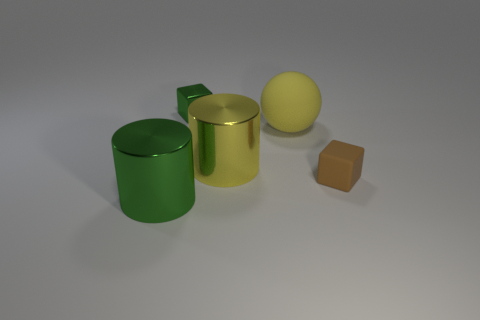What can be inferred about the setting in which these objects are placed? The setting seems to be a controlled environment with neutral background, possibly a digital rendering or a studio composed for showcasing the objects. The soft shadows indicate a single light source, likely constructed for the purpose of the display. 